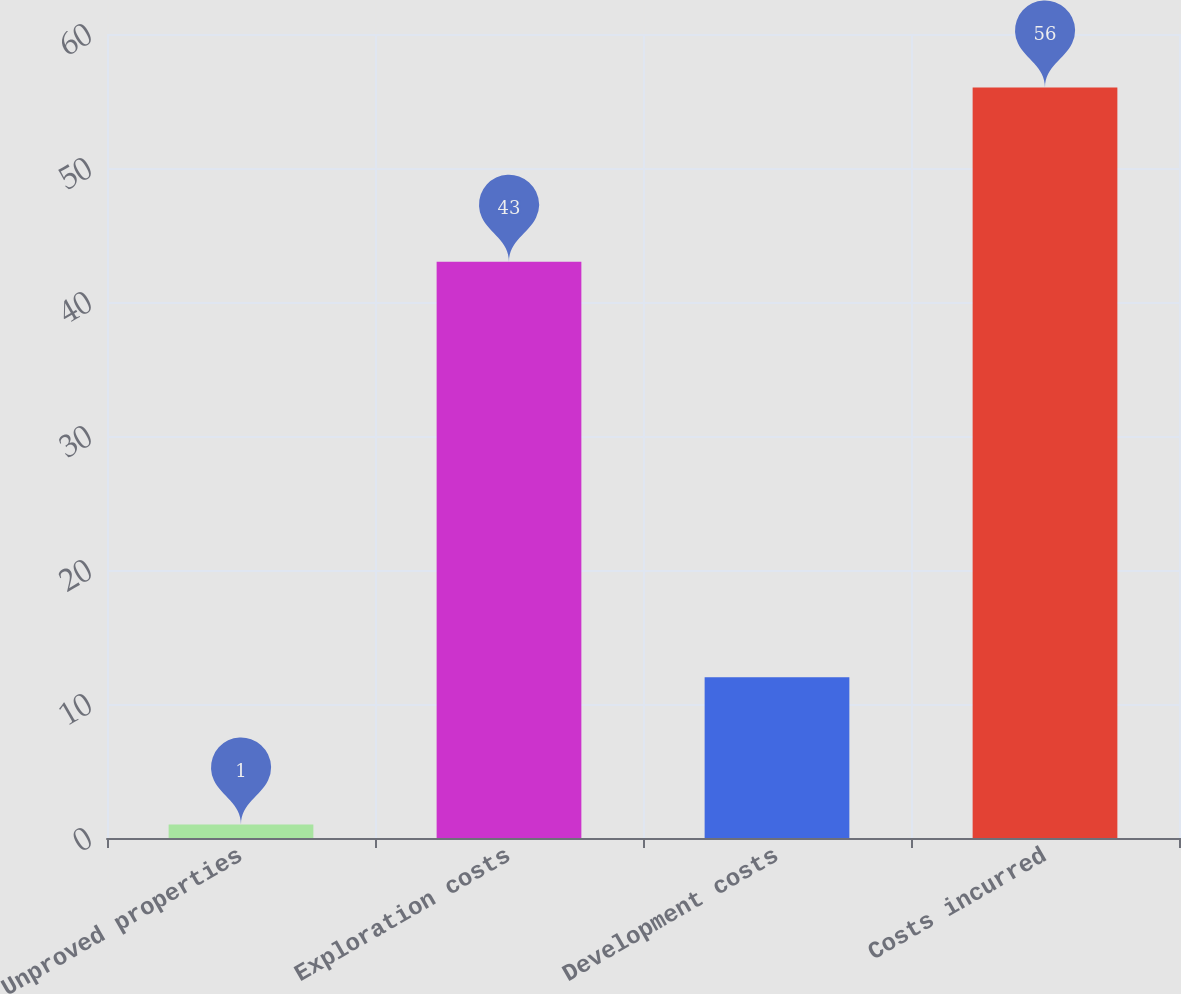<chart> <loc_0><loc_0><loc_500><loc_500><bar_chart><fcel>Unproved properties<fcel>Exploration costs<fcel>Development costs<fcel>Costs incurred<nl><fcel>1<fcel>43<fcel>12<fcel>56<nl></chart> 